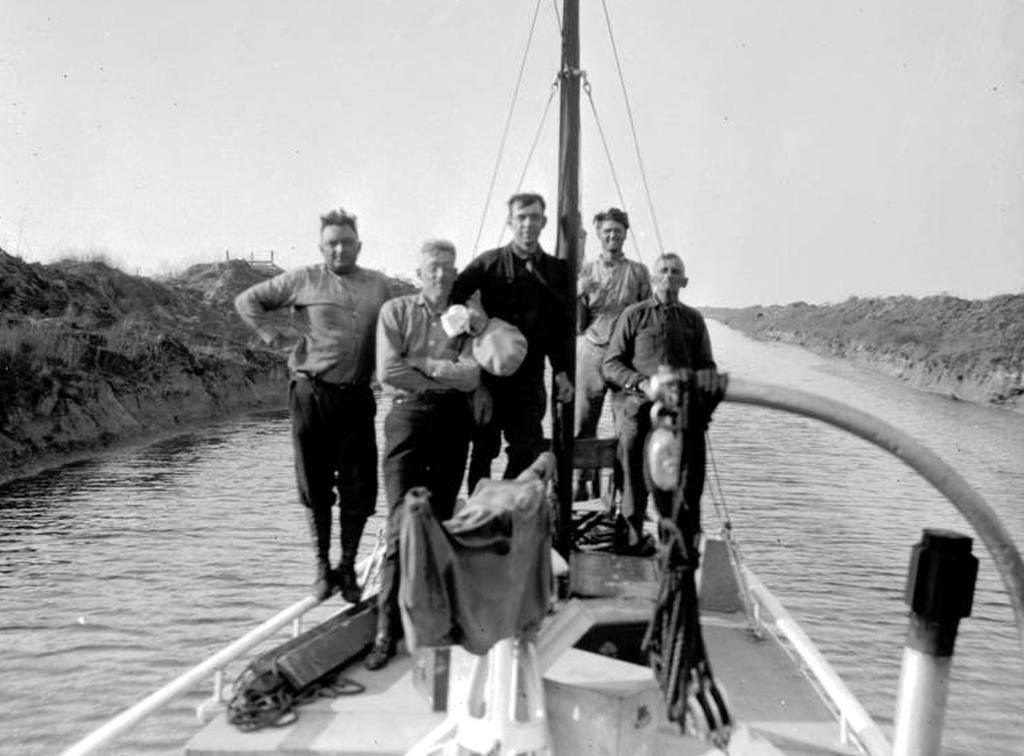What is the color scheme of the image? The image is black and white. What can be seen in the center of the image? There are people standing in a boat in the center of the image. What is the background of the image? There is water in the background of the image. What else is visible in the image? The sky is visible in the image. What type of list is being held by the people in the boat? There is no list present in the image; the people are standing in a boat in the water. Can you see a gate in the image? There is no gate present in the image; it features people in a boat on water with a visible sky. 